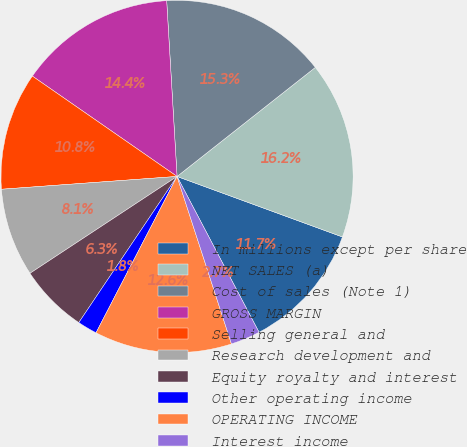Convert chart. <chart><loc_0><loc_0><loc_500><loc_500><pie_chart><fcel>In millions except per share<fcel>NET SALES (a)<fcel>Cost of sales (Note 1)<fcel>GROSS MARGIN<fcel>Selling general and<fcel>Research development and<fcel>Equity royalty and interest<fcel>Other operating income<fcel>OPERATING INCOME<fcel>Interest income<nl><fcel>11.71%<fcel>16.21%<fcel>15.31%<fcel>14.41%<fcel>10.81%<fcel>8.11%<fcel>6.31%<fcel>1.81%<fcel>12.61%<fcel>2.71%<nl></chart> 